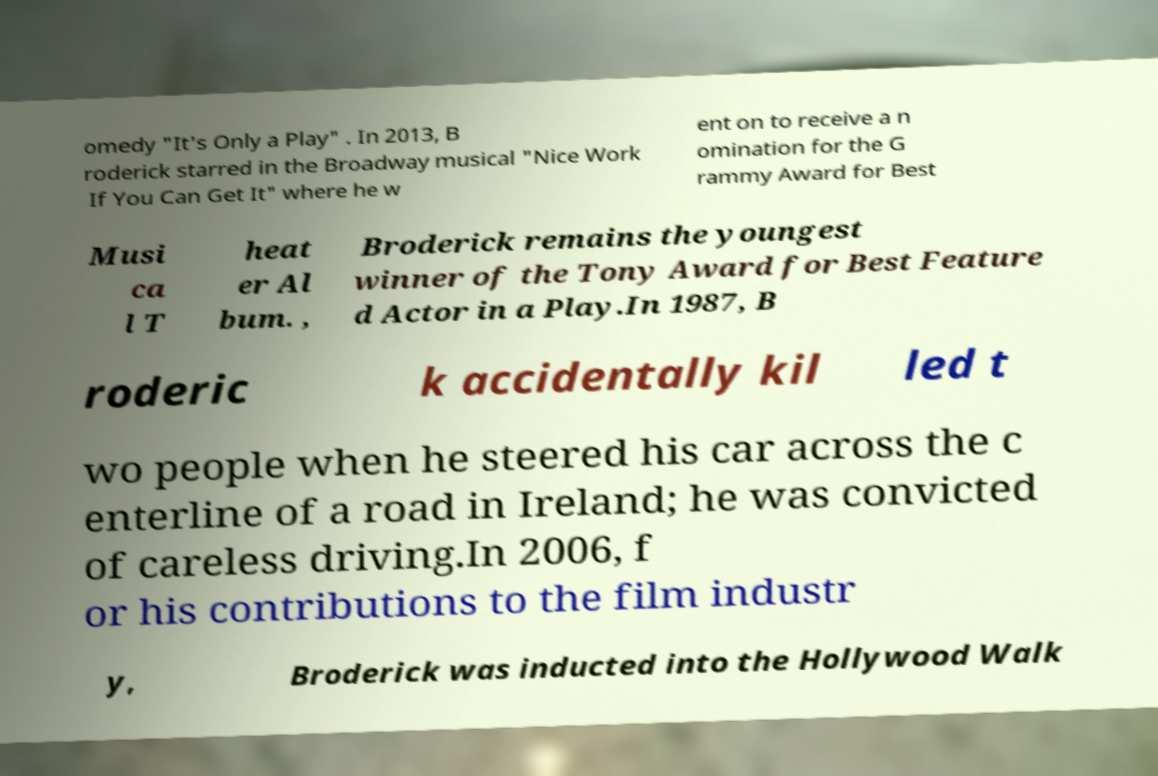For documentation purposes, I need the text within this image transcribed. Could you provide that? omedy "It's Only a Play" . In 2013, B roderick starred in the Broadway musical "Nice Work If You Can Get It" where he w ent on to receive a n omination for the G rammy Award for Best Musi ca l T heat er Al bum. , Broderick remains the youngest winner of the Tony Award for Best Feature d Actor in a Play.In 1987, B roderic k accidentally kil led t wo people when he steered his car across the c enterline of a road in Ireland; he was convicted of careless driving.In 2006, f or his contributions to the film industr y, Broderick was inducted into the Hollywood Walk 